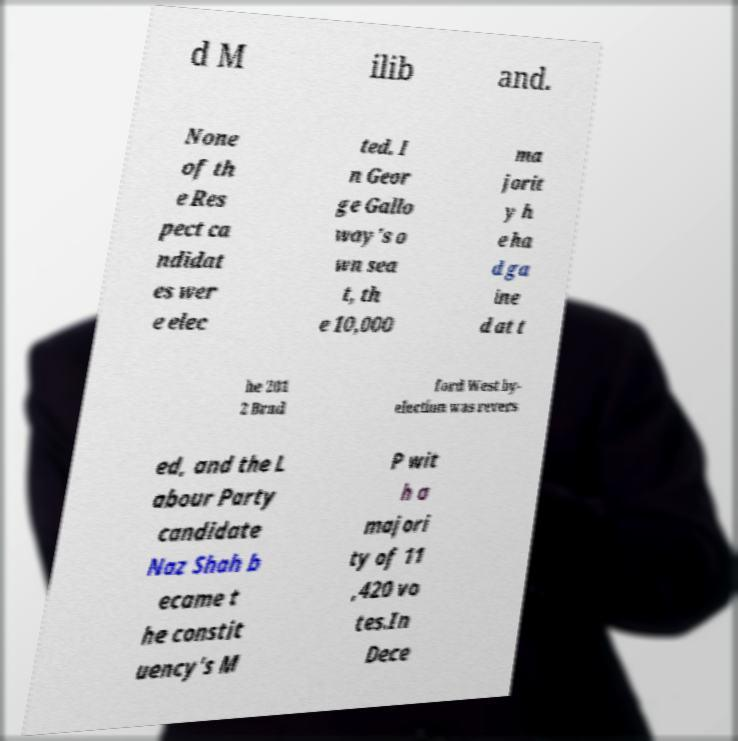Could you extract and type out the text from this image? d M ilib and. None of th e Res pect ca ndidat es wer e elec ted. I n Geor ge Gallo way's o wn sea t, th e 10,000 ma jorit y h e ha d ga ine d at t he 201 2 Brad ford West by- election was revers ed, and the L abour Party candidate Naz Shah b ecame t he constit uency's M P wit h a majori ty of 11 ,420 vo tes.In Dece 